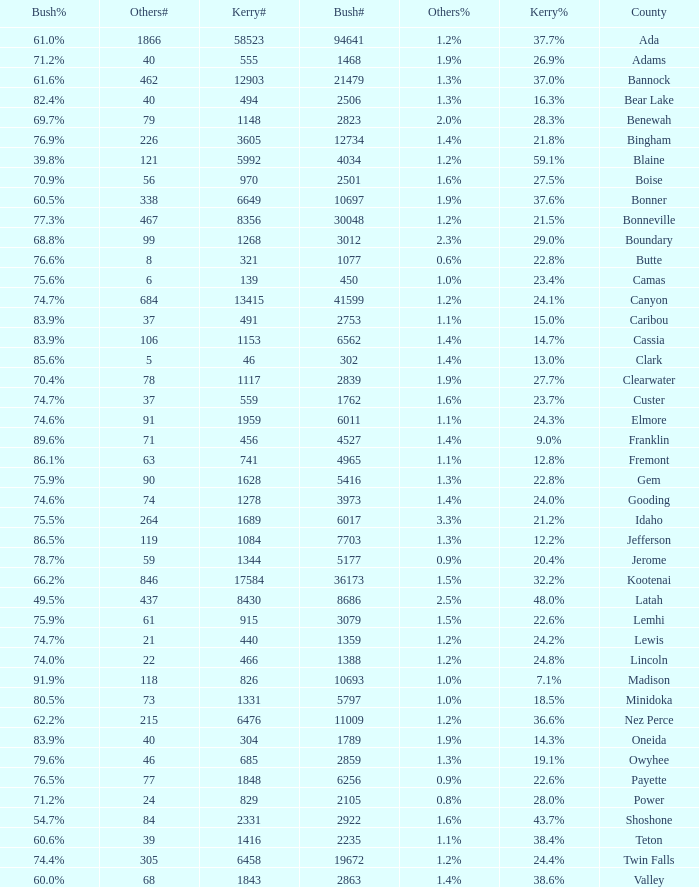What's percentage voted for Busg in the county where Kerry got 37.6%? 60.5%. 